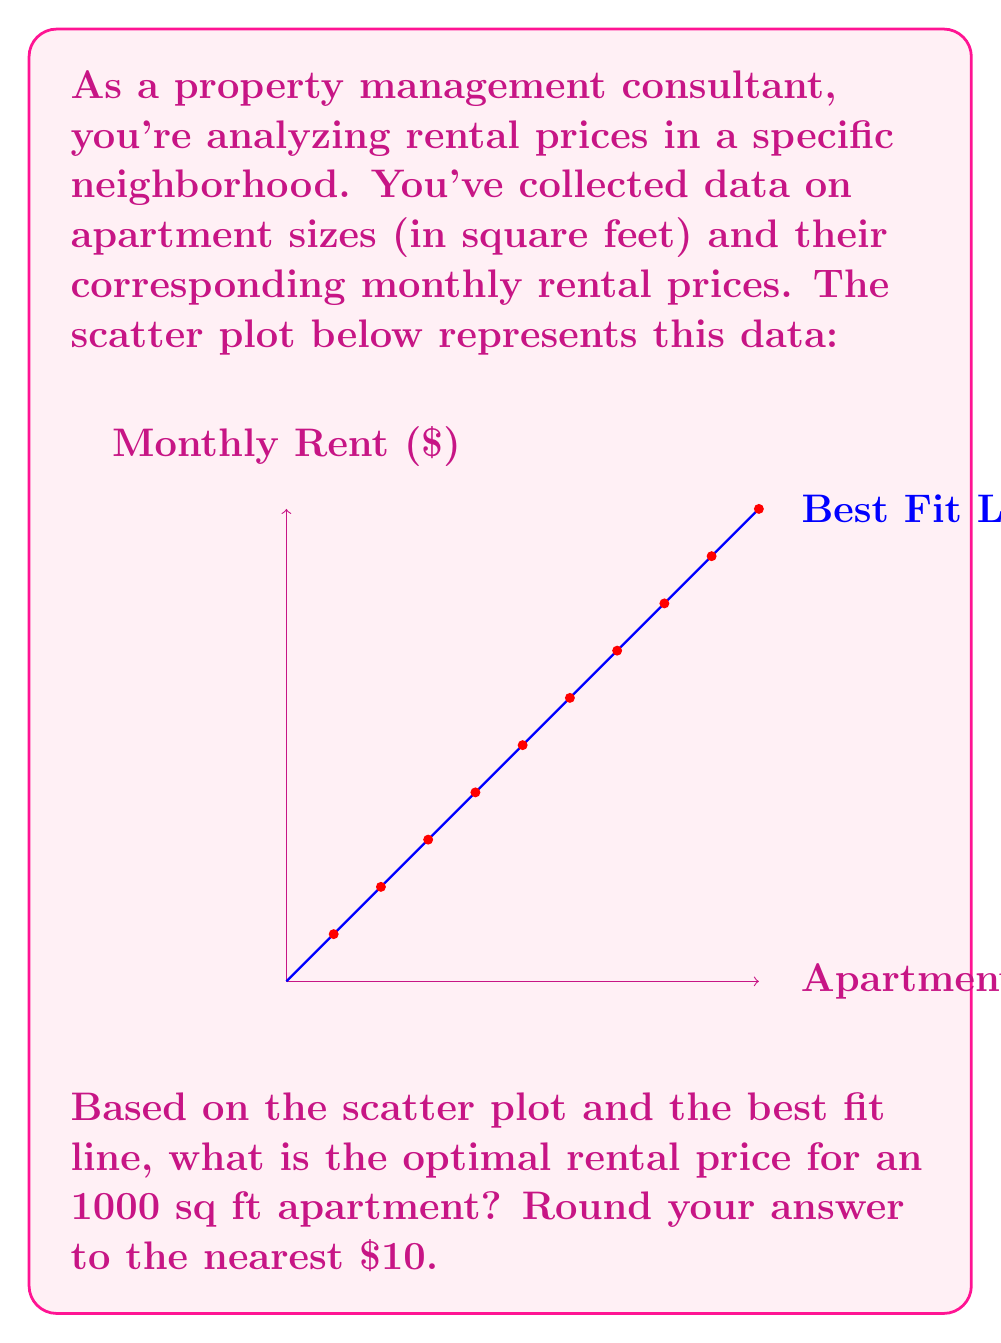Solve this math problem. To solve this problem, we need to use the best fit line (linear regression) shown in the scatter plot. Here's how we can approach it:

1) First, we need to determine the equation of the best fit line. The general form is $y = mx + b$, where:
   $y$ is the monthly rent
   $x$ is the apartment size in square feet
   $m$ is the slope of the line
   $b$ is the y-intercept

2) From the scatter plot, we can estimate two points on the line:
   Point 1: (500, 800)
   Point 2: (1400, 1700)

3) We can calculate the slope $(m)$ using these points:
   $$m = \frac{y_2 - y_1}{x_2 - x_1} = \frac{1700 - 800}{1400 - 500} = \frac{900}{900} = 1$$

4) This means that for every 1 sq ft increase in size, the rent increases by $1.

5) To find $b$ (y-intercept), we can use either point. Let's use (500, 800):
   $800 = 1(500) + b$
   $b = 800 - 500 = 300$

6) So, our equation is: $y = 1x + 300$

7) For a 1000 sq ft apartment, we plug in $x = 1000$:
   $y = 1(1000) + 300 = 1300$

8) Rounding to the nearest $10: $1300

Therefore, based on this linear model, the optimal rental price for a 1000 sq ft apartment would be $1300 per month.
Answer: $1300 